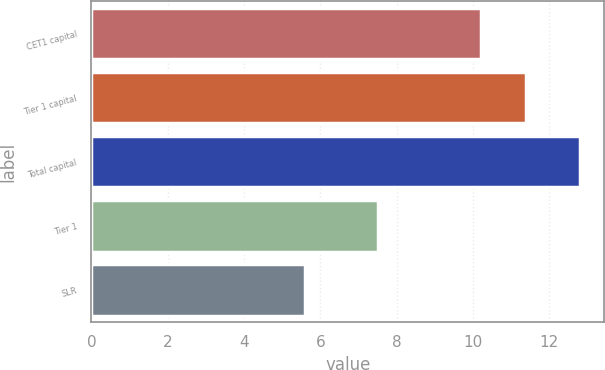Convert chart. <chart><loc_0><loc_0><loc_500><loc_500><bar_chart><fcel>CET1 capital<fcel>Tier 1 capital<fcel>Total capital<fcel>Tier 1<fcel>SLR<nl><fcel>10.2<fcel>11.4<fcel>12.8<fcel>7.5<fcel>5.6<nl></chart> 